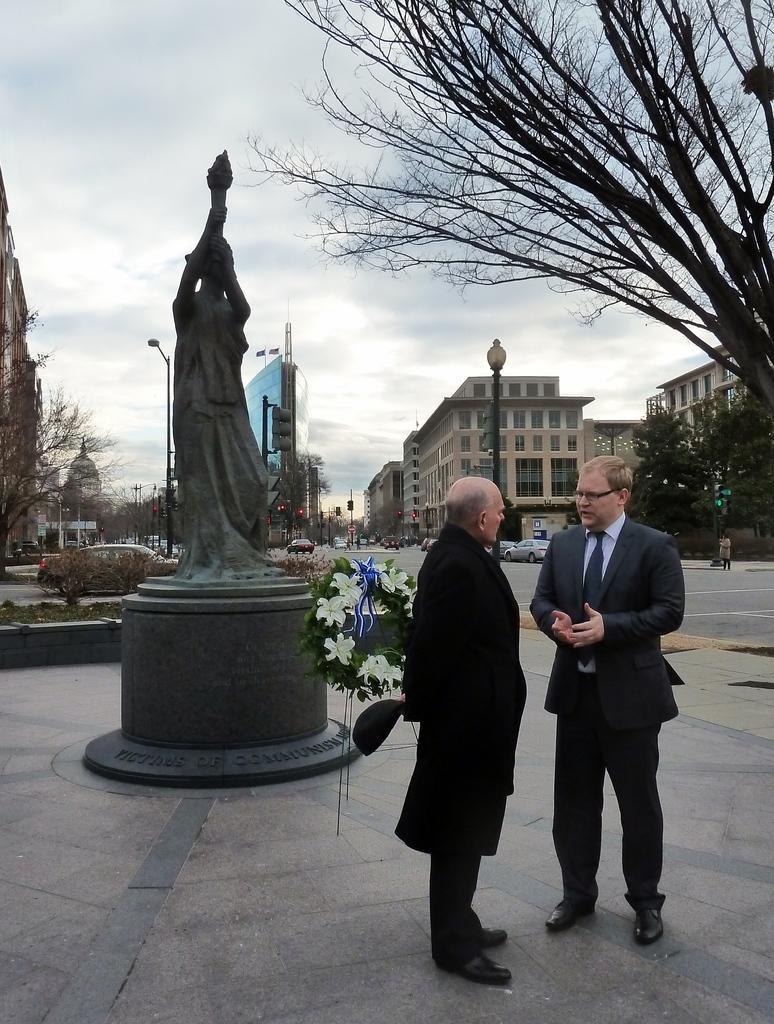How many people are visible in the image? There are two people standing on the right side of the image. What can be seen on the left side of the image? There is a statue on the left side of the image. What is visible in the background of the image? There are poles, buildings, trees, cars, and the sky visible in the background of the image. Is there a nail holding the statue in place in the image? There is no mention of a nail or any specific method of securing the statue in the image. 